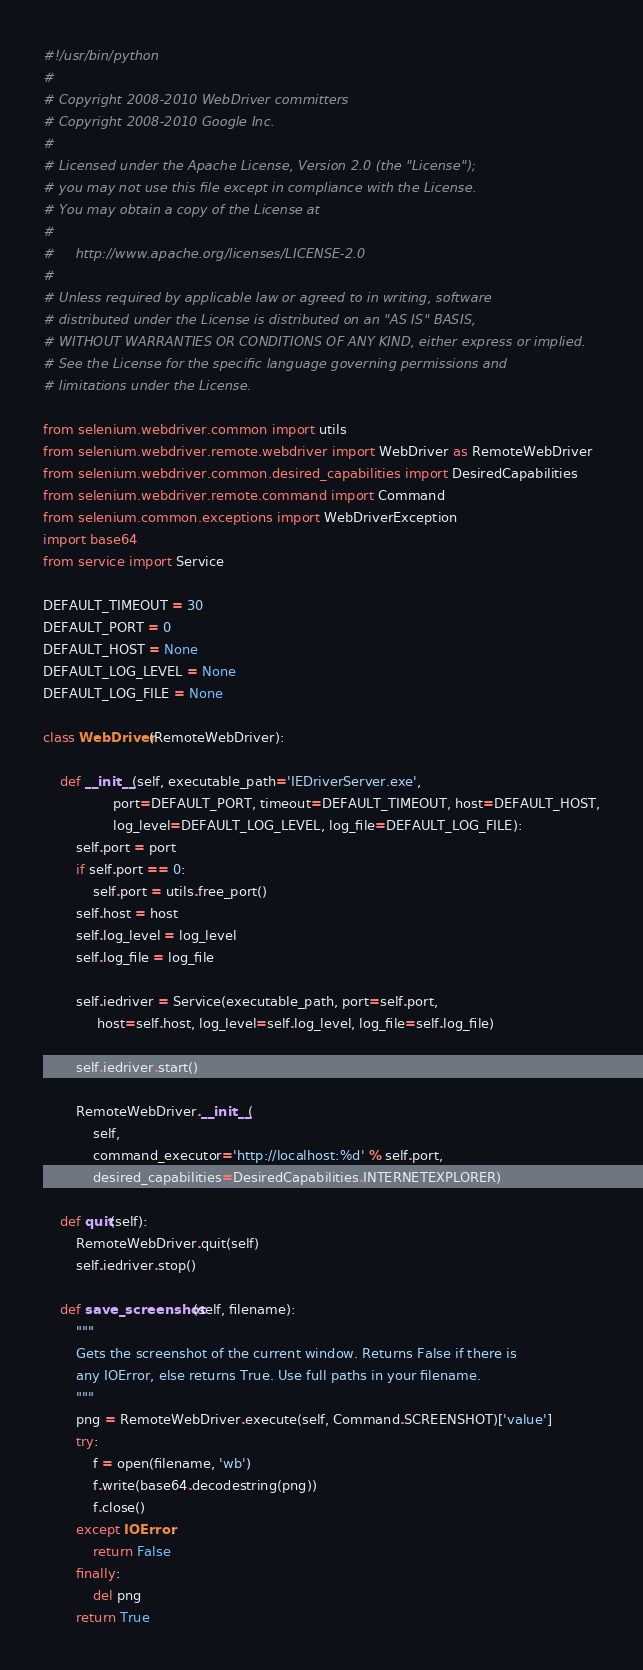<code> <loc_0><loc_0><loc_500><loc_500><_Python_>#!/usr/bin/python
#
# Copyright 2008-2010 WebDriver committers
# Copyright 2008-2010 Google Inc.
#
# Licensed under the Apache License, Version 2.0 (the "License");
# you may not use this file except in compliance with the License.
# You may obtain a copy of the License at
#
#     http://www.apache.org/licenses/LICENSE-2.0
#
# Unless required by applicable law or agreed to in writing, software
# distributed under the License is distributed on an "AS IS" BASIS,
# WITHOUT WARRANTIES OR CONDITIONS OF ANY KIND, either express or implied.
# See the License for the specific language governing permissions and
# limitations under the License.

from selenium.webdriver.common import utils
from selenium.webdriver.remote.webdriver import WebDriver as RemoteWebDriver
from selenium.webdriver.common.desired_capabilities import DesiredCapabilities
from selenium.webdriver.remote.command import Command
from selenium.common.exceptions import WebDriverException
import base64
from service import Service

DEFAULT_TIMEOUT = 30
DEFAULT_PORT = 0
DEFAULT_HOST = None
DEFAULT_LOG_LEVEL = None
DEFAULT_LOG_FILE = None

class WebDriver(RemoteWebDriver):

    def __init__(self, executable_path='IEDriverServer.exe', 
                 port=DEFAULT_PORT, timeout=DEFAULT_TIMEOUT, host=DEFAULT_HOST,
                 log_level=DEFAULT_LOG_LEVEL, log_file=DEFAULT_LOG_FILE):
        self.port = port
        if self.port == 0:
            self.port = utils.free_port()
        self.host = host
        self.log_level = log_level
        self.log_file = log_file

        self.iedriver = Service(executable_path, port=self.port,
             host=self.host, log_level=self.log_level, log_file=self.log_file)

        self.iedriver.start()

        RemoteWebDriver.__init__(
            self,
            command_executor='http://localhost:%d' % self.port,
            desired_capabilities=DesiredCapabilities.INTERNETEXPLORER)

    def quit(self):
        RemoteWebDriver.quit(self)
        self.iedriver.stop()

    def save_screenshot(self, filename):
        """
        Gets the screenshot of the current window. Returns False if there is
        any IOError, else returns True. Use full paths in your filename.
        """
        png = RemoteWebDriver.execute(self, Command.SCREENSHOT)['value']
        try:
            f = open(filename, 'wb')
            f.write(base64.decodestring(png))
            f.close()
        except IOError:
            return False
        finally:
            del png
        return True
</code> 